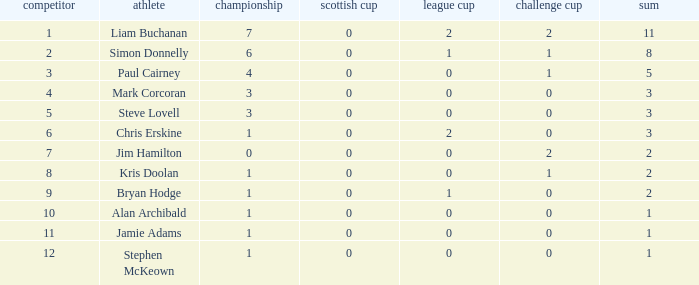What was player 7's score in the challenge cup? 1.0. 